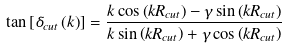<formula> <loc_0><loc_0><loc_500><loc_500>\tan \left [ \delta _ { c u t } \left ( k \right ) \right ] = \frac { k \cos \left ( k R _ { c u t } \right ) - \gamma \sin \left ( k R _ { c u t } \right ) } { k \sin \left ( k R _ { c u t } \right ) + \gamma \cos \left ( k R _ { c u t } \right ) }</formula> 